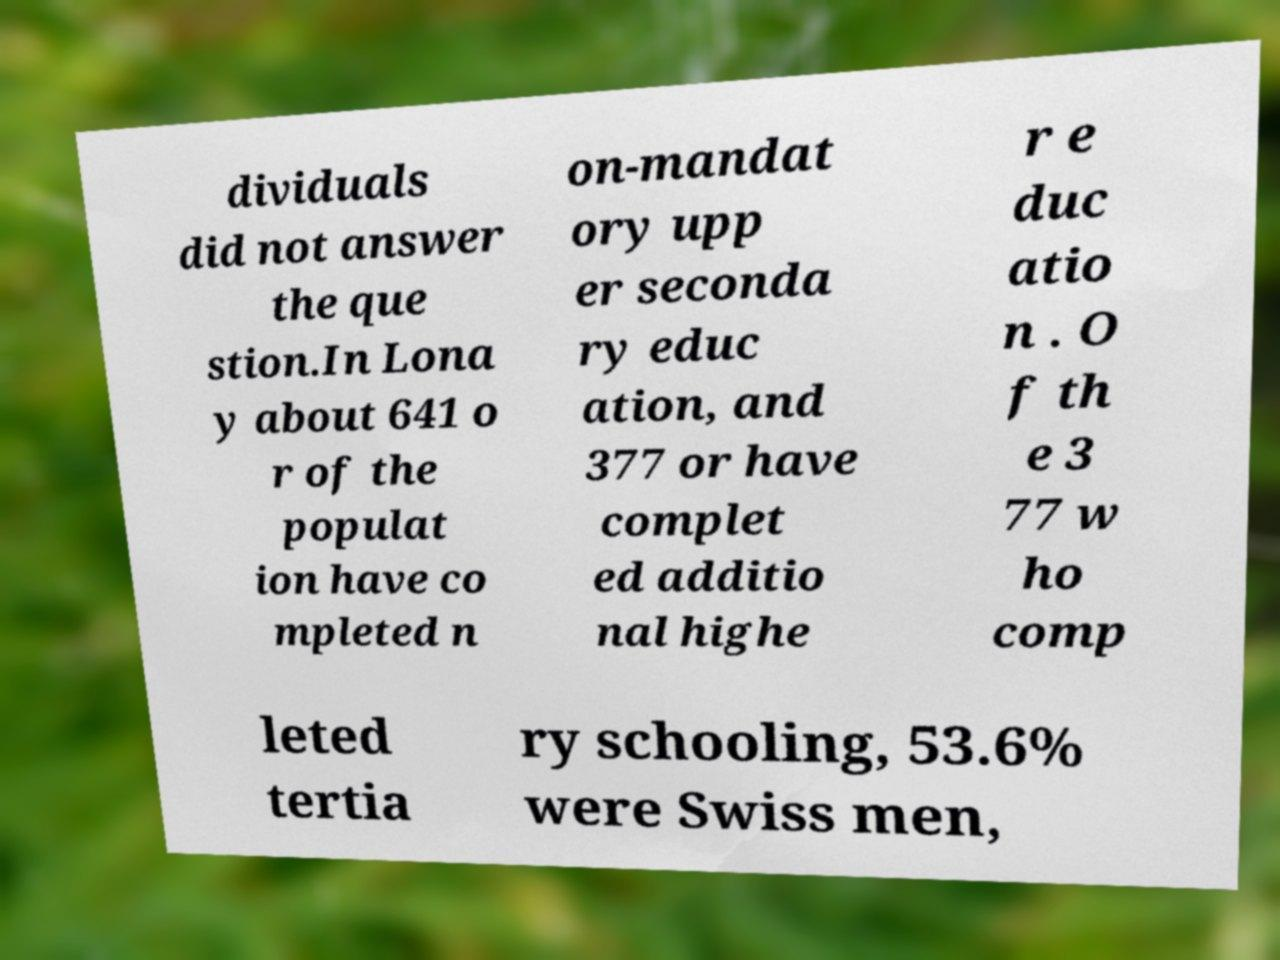Please identify and transcribe the text found in this image. dividuals did not answer the que stion.In Lona y about 641 o r of the populat ion have co mpleted n on-mandat ory upp er seconda ry educ ation, and 377 or have complet ed additio nal highe r e duc atio n . O f th e 3 77 w ho comp leted tertia ry schooling, 53.6% were Swiss men, 